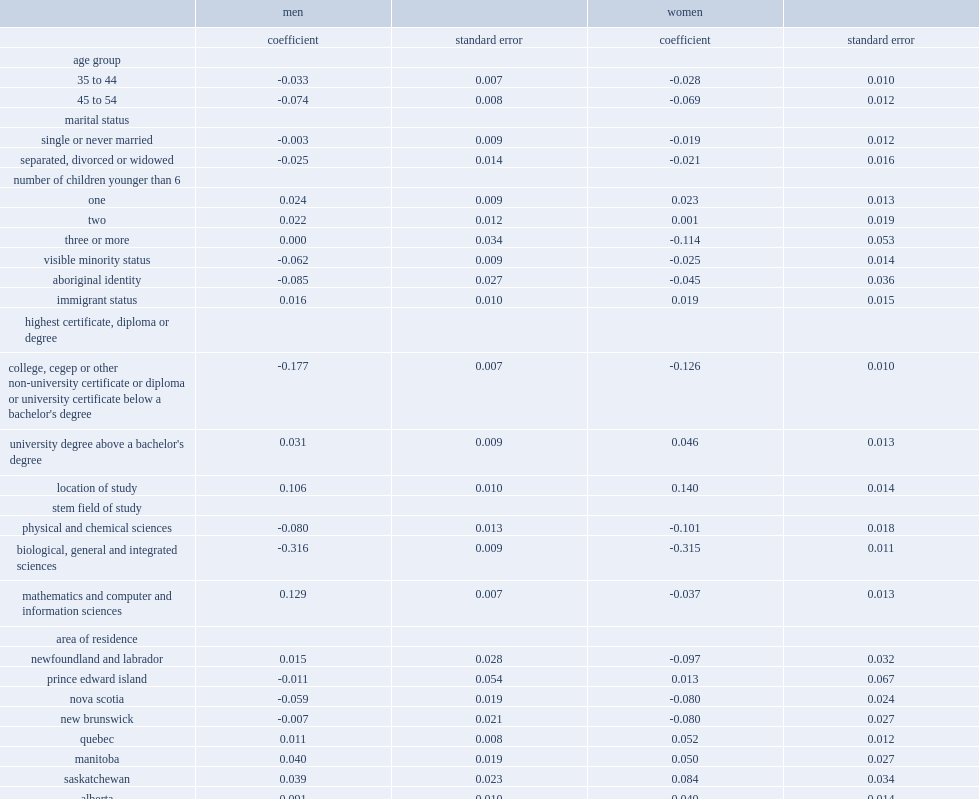Who were less likely to work in a stem occupation,men and women who identified as visible minorities or their counterparts who did not identify as a minority? Visible minority status. Who were less likely to be employed in a stem occupation in 2006,aboriginal men with stem credentials or their non-aboriginal counterparts? Aboriginal identity. Who were less likely to be employed in a stem occupation,stem graduates who held a college diploma or a university certificate below the bachelor's level or bachelor's degree holders. College, cegep or other non-university certificate or diploma or university certificate below a bachelor's degree. Who were more likely to work in a stem occupation,men and women who obtained their stem credentials in canada or their counterparts who studied outside canada? Area of residence. Who were less likely to be working in stem occupations,men and women who studied physical or chemical sciences or biological, general or integrated sciences or their counterparts who studied engineering or engineering technology? Physical and chemical sciences biological, general and integrated sciences. Who were more likely to be working in a stem occupation, men who studied mathematics or computer and information sciences or men who studied engineering or engineering technology? Mathematics and computer and information sciences. Who were less likely to be employed in a stem occupation than women who had studied engineering or engineering technology,women who studied mathematics or computer and information sciences or women who had studied engineering or engineering technology? Mathematics and computer and information sciences. 